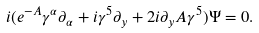Convert formula to latex. <formula><loc_0><loc_0><loc_500><loc_500>i ( e ^ { - A } \gamma ^ { \alpha } \partial _ { \alpha } + i \gamma ^ { 5 } \partial _ { y } + 2 i \partial _ { y } A \gamma ^ { 5 } ) \Psi = 0 .</formula> 